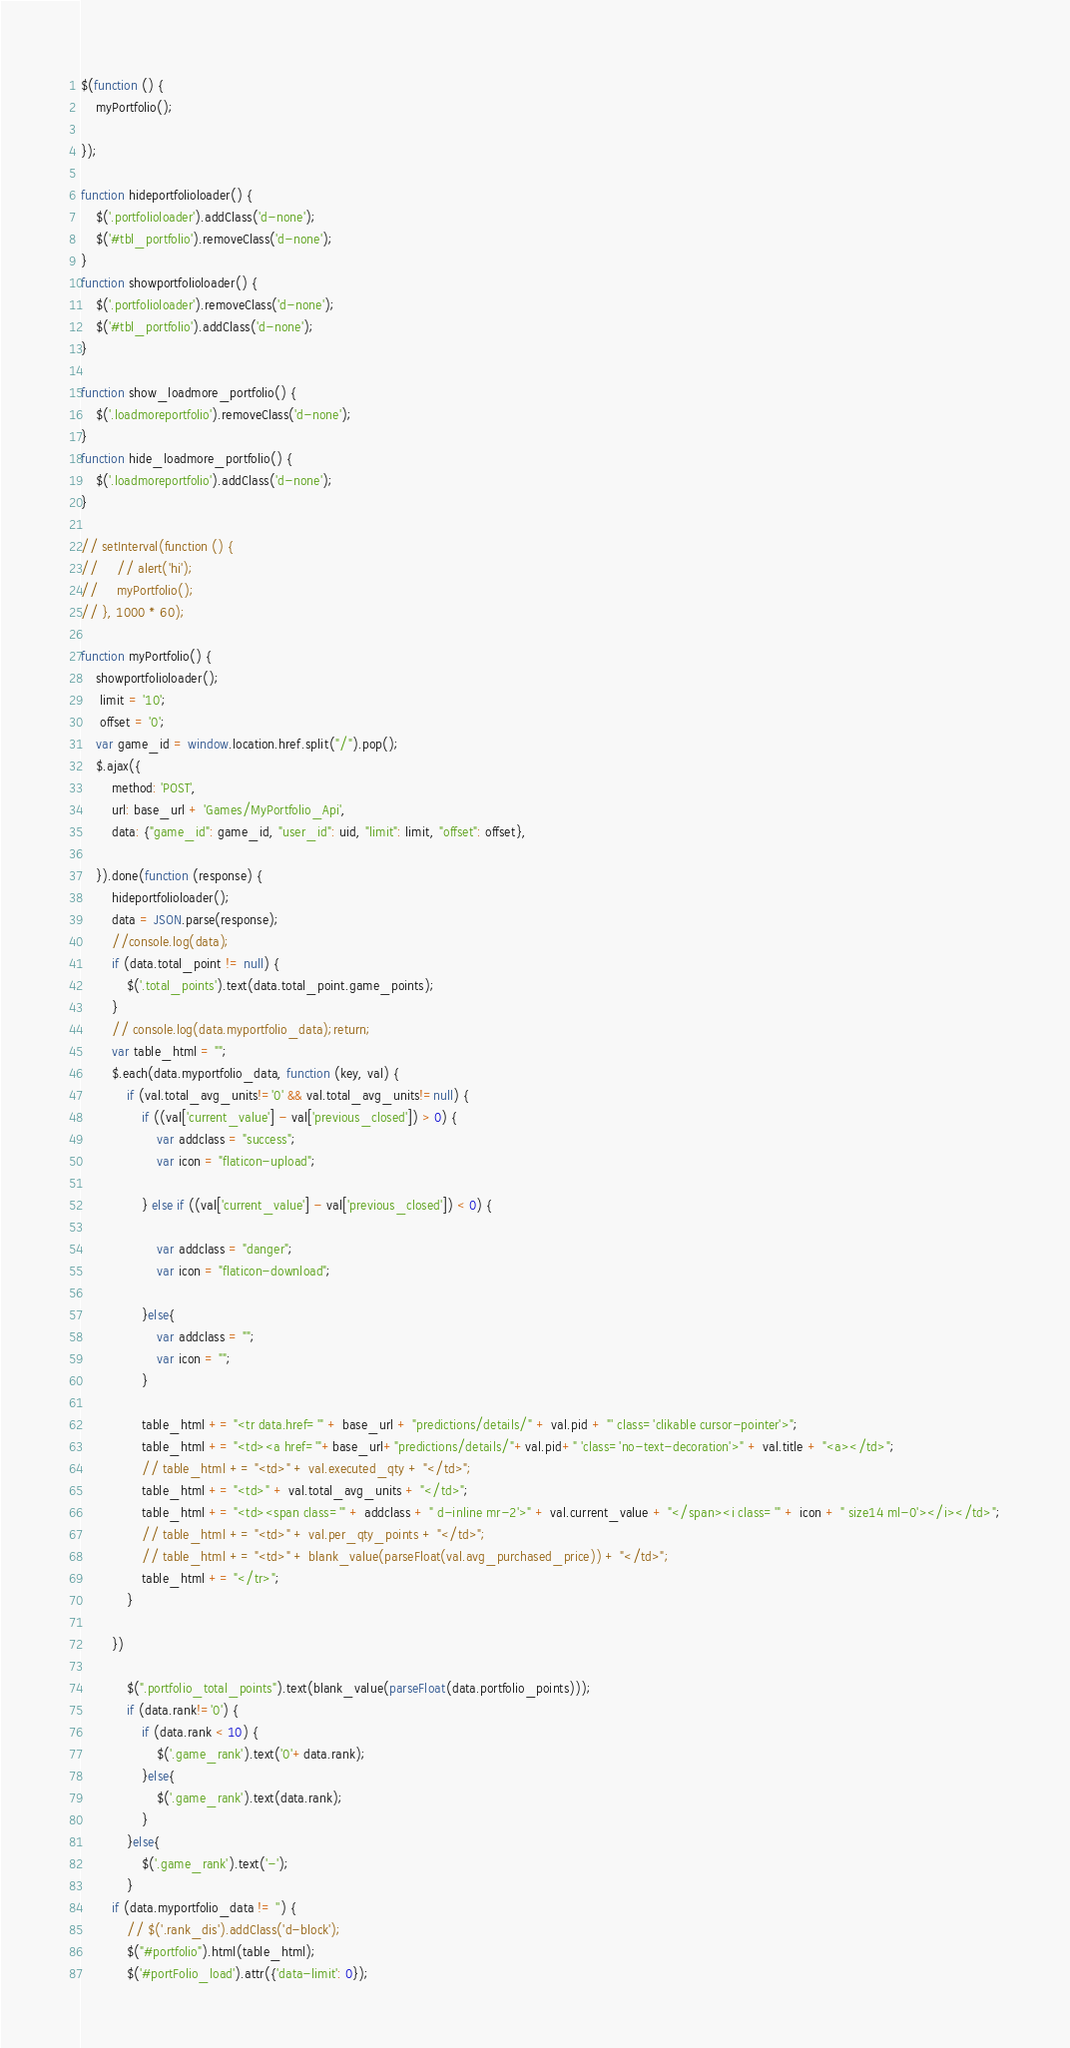<code> <loc_0><loc_0><loc_500><loc_500><_JavaScript_>$(function () {
    myPortfolio();

});

function hideportfolioloader() {
    $('.portfolioloader').addClass('d-none');
    $('#tbl_portfolio').removeClass('d-none');
}
function showportfolioloader() {
    $('.portfolioloader').removeClass('d-none');
    $('#tbl_portfolio').addClass('d-none');
}

function show_loadmore_portfolio() {
    $('.loadmoreportfolio').removeClass('d-none');
}
function hide_loadmore_portfolio() {
    $('.loadmoreportfolio').addClass('d-none');
}

// setInterval(function () {
//     // alert('hi');
//     myPortfolio();
// }, 1000 * 60);

function myPortfolio() {
    showportfolioloader();
     limit = '10';
     offset = '0';
    var game_id = window.location.href.split("/").pop();
    $.ajax({
        method: 'POST',
        url: base_url + 'Games/MyPortfolio_Api',
        data: {"game_id": game_id, "user_id": uid, "limit": limit, "offset": offset},

    }).done(function (response) {
        hideportfolioloader();
        data = JSON.parse(response);
        //console.log(data);
        if (data.total_point != null) {
            $('.total_points').text(data.total_point.game_points);
        }
        // console.log(data.myportfolio_data);return;
        var table_html = "";
        $.each(data.myportfolio_data, function (key, val) {
            if (val.total_avg_units!='0' && val.total_avg_units!=null) {
                if ((val['current_value'] - val['previous_closed']) > 0) {
                    var addclass = "success";
                    var icon = "flaticon-upload";

                } else if ((val['current_value'] - val['previous_closed']) < 0) {

                    var addclass = "danger";
                    var icon = "flaticon-download";

                }else{
                    var addclass = "";
                    var icon = "";                
                }

                table_html += "<tr data.href='" + base_url + "predictions/details/" + val.pid + "' class='clikable cursor-pointer'>";
                table_html += "<td><a href='"+base_url+"predictions/details/"+val.pid+" 'class='no-text-decoration'>" + val.title + "<a></td>";
                // table_html += "<td>" + val.executed_qty + "</td>";
                table_html += "<td>" + val.total_avg_units + "</td>";
                table_html += "<td><span class='" + addclass + " d-inline mr-2'>" + val.current_value + "</span><i class='" + icon + " size14 ml-0'></i></td>";
                // table_html += "<td>" + val.per_qty_points + "</td>";
                // table_html += "<td>" + blank_value(parseFloat(val.avg_purchased_price)) + "</td>";
                table_html += "</tr>";
            }

        })
      
            $(".portfolio_total_points").text(blank_value(parseFloat(data.portfolio_points)));
            if (data.rank!='0') {
                if (data.rank < 10) {
                    $('.game_rank').text('0'+data.rank);
                }else{
                    $('.game_rank').text(data.rank);
                }
            }else{
                $('.game_rank').text('-');
            }
        if (data.myportfolio_data != '') {
            // $('.rank_dis').addClass('d-block');
            $("#portfolio").html(table_html);
            $('#portFolio_load').attr({'data-limit': 0});</code> 